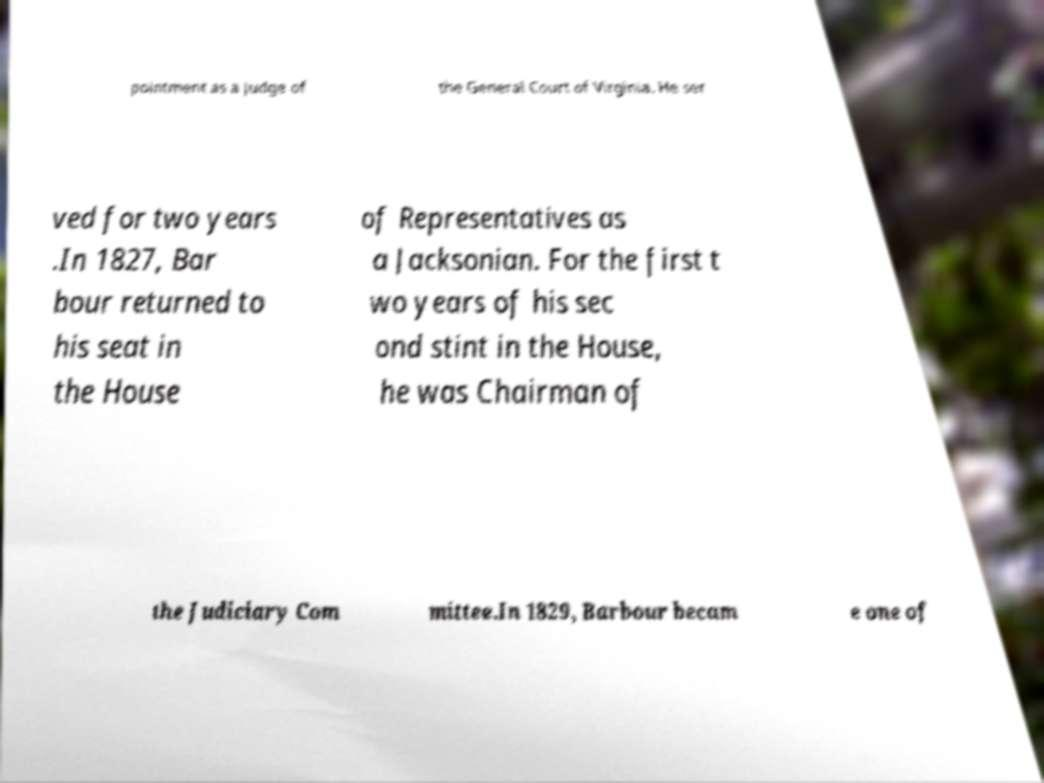Could you assist in decoding the text presented in this image and type it out clearly? pointment as a judge of the General Court of Virginia. He ser ved for two years .In 1827, Bar bour returned to his seat in the House of Representatives as a Jacksonian. For the first t wo years of his sec ond stint in the House, he was Chairman of the Judiciary Com mittee.In 1829, Barbour becam e one of 